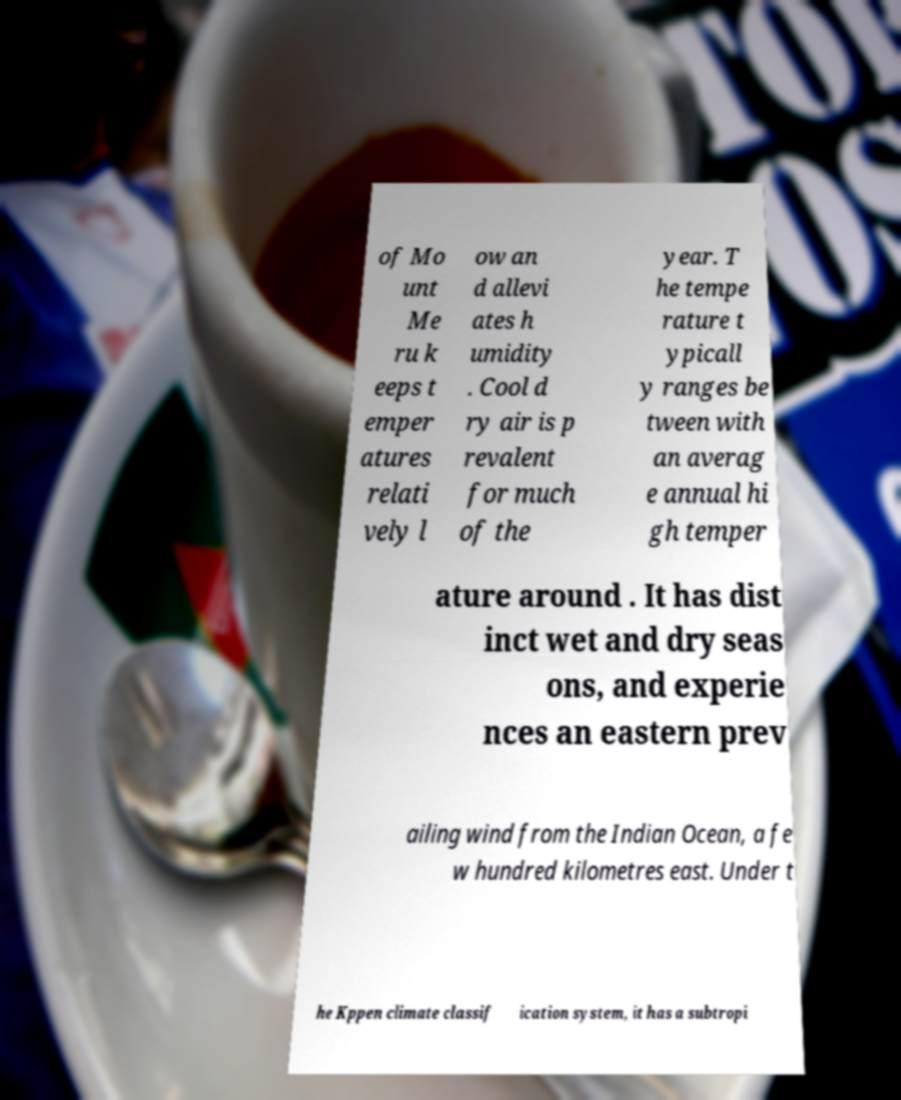Could you assist in decoding the text presented in this image and type it out clearly? of Mo unt Me ru k eeps t emper atures relati vely l ow an d allevi ates h umidity . Cool d ry air is p revalent for much of the year. T he tempe rature t ypicall y ranges be tween with an averag e annual hi gh temper ature around . It has dist inct wet and dry seas ons, and experie nces an eastern prev ailing wind from the Indian Ocean, a fe w hundred kilometres east. Under t he Kppen climate classif ication system, it has a subtropi 